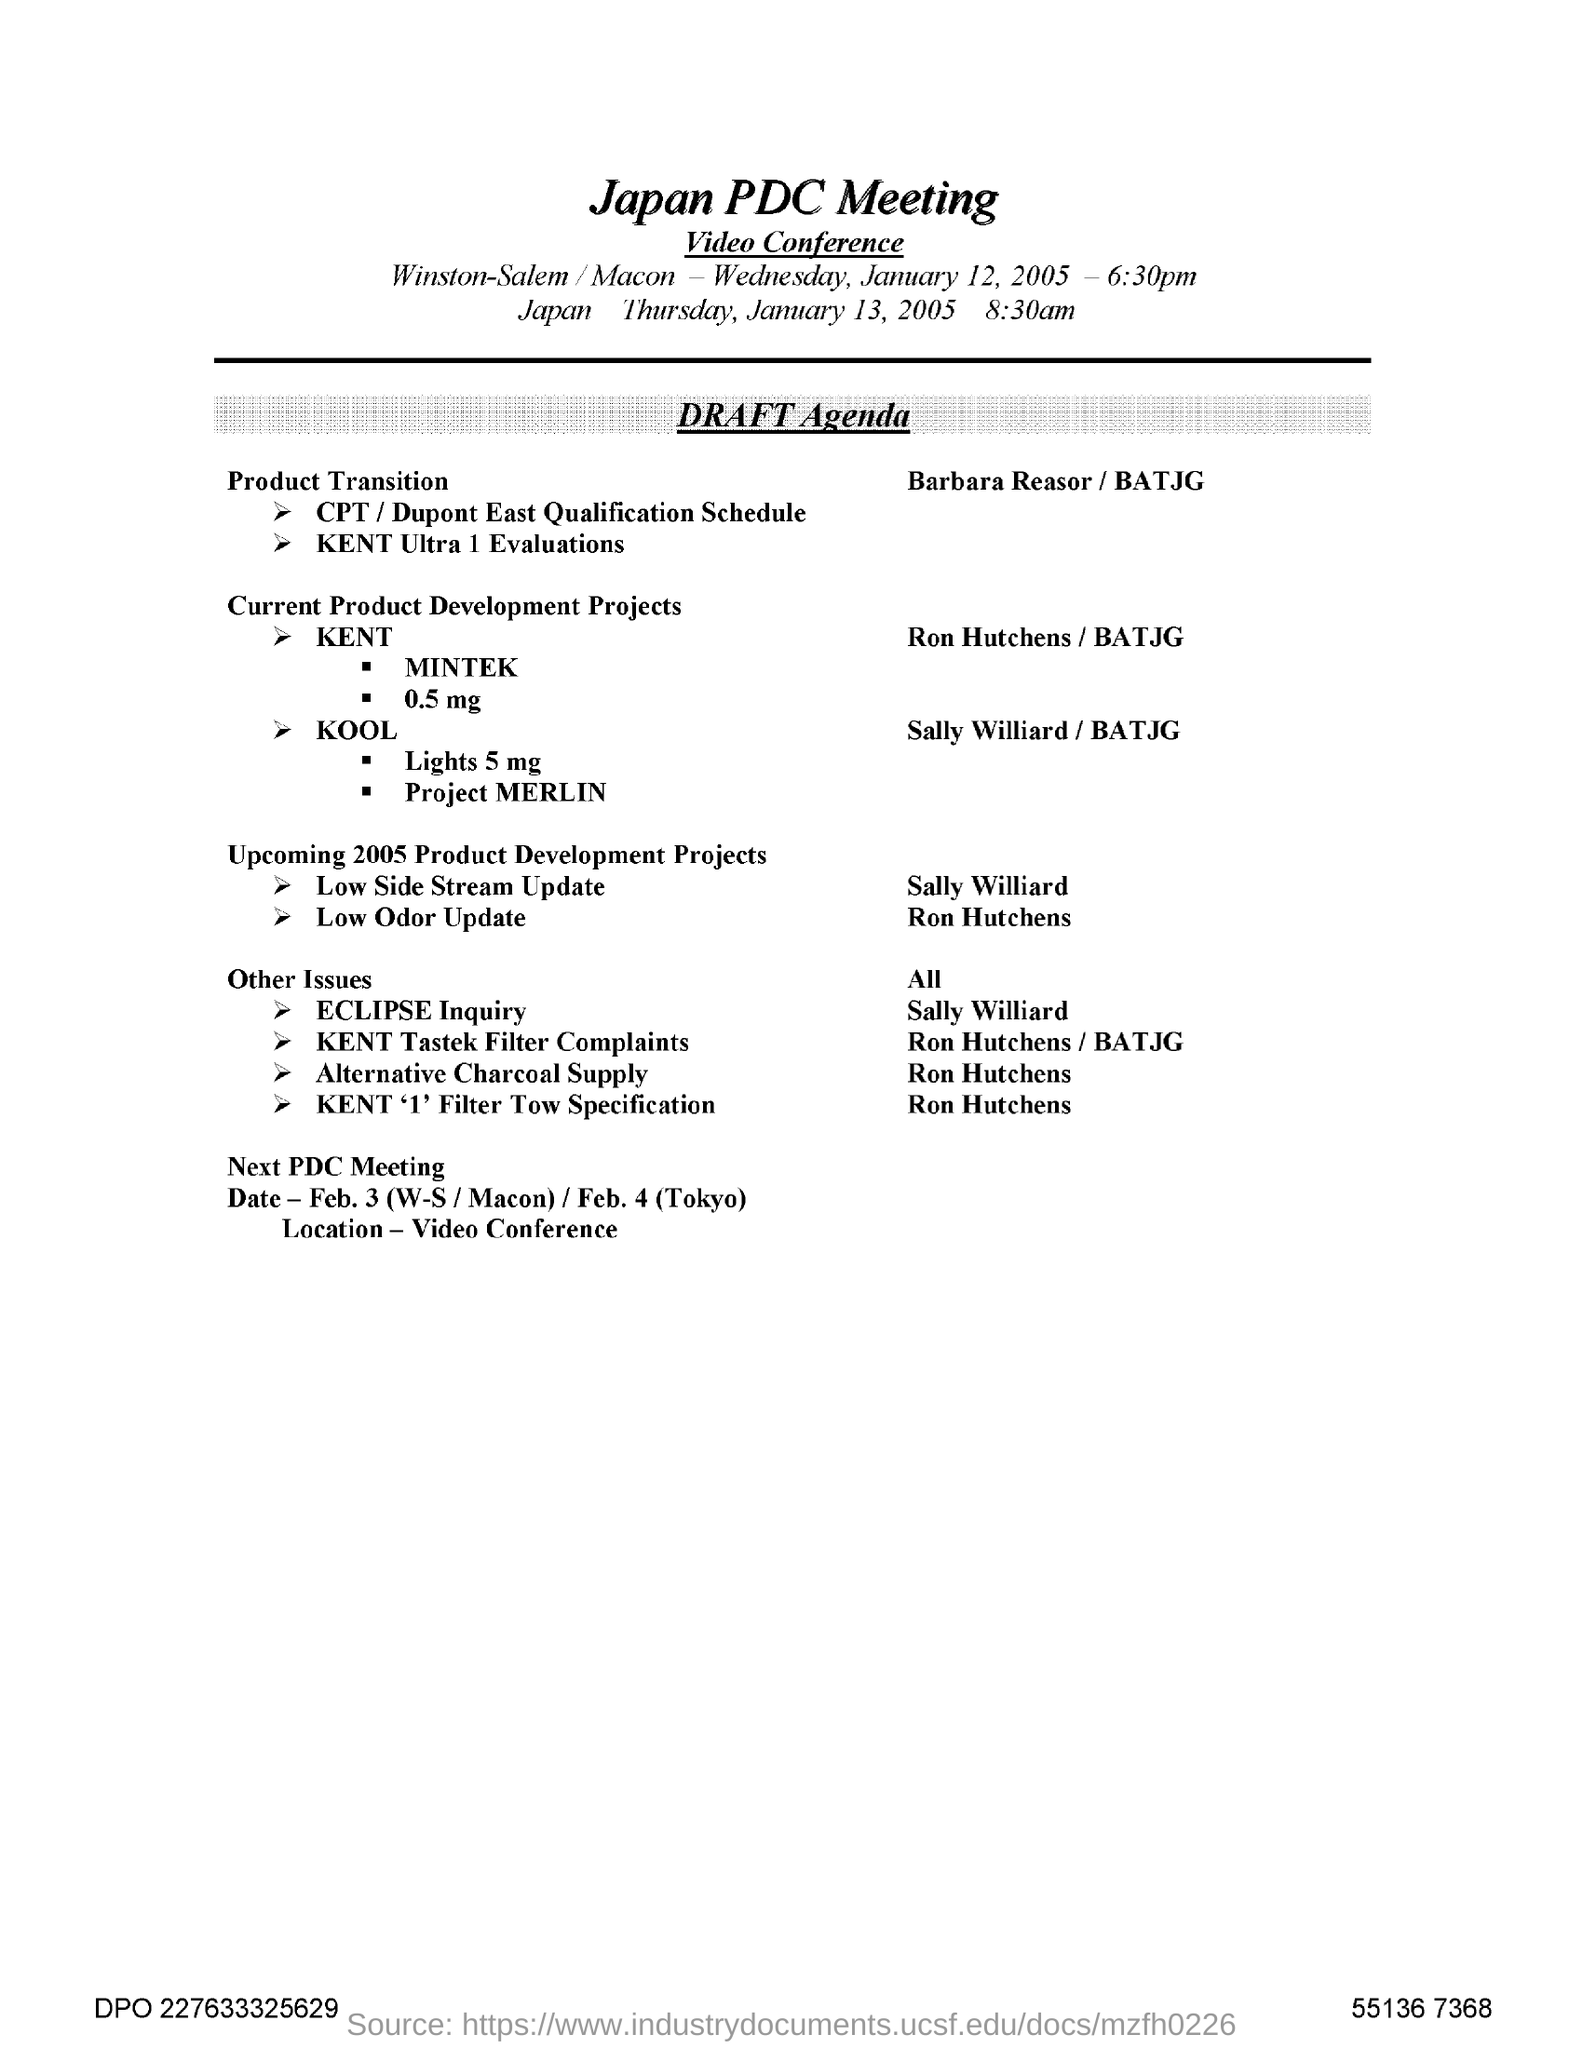Which meeting agenda is given here?
Offer a very short reply. Japan PDC Meeting. 